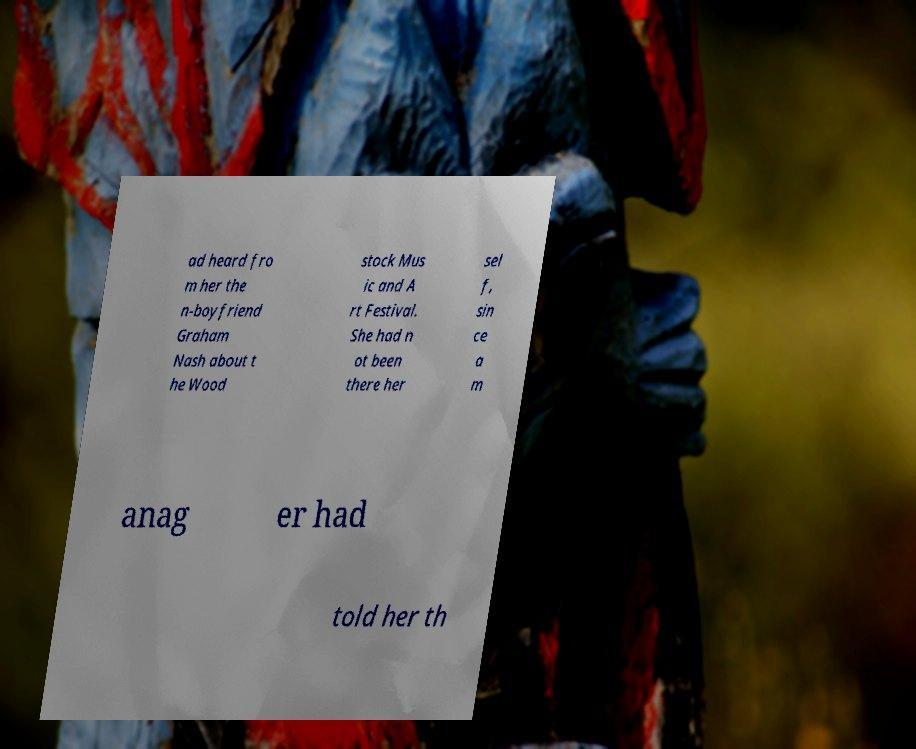I need the written content from this picture converted into text. Can you do that? ad heard fro m her the n-boyfriend Graham Nash about t he Wood stock Mus ic and A rt Festival. She had n ot been there her sel f, sin ce a m anag er had told her th 